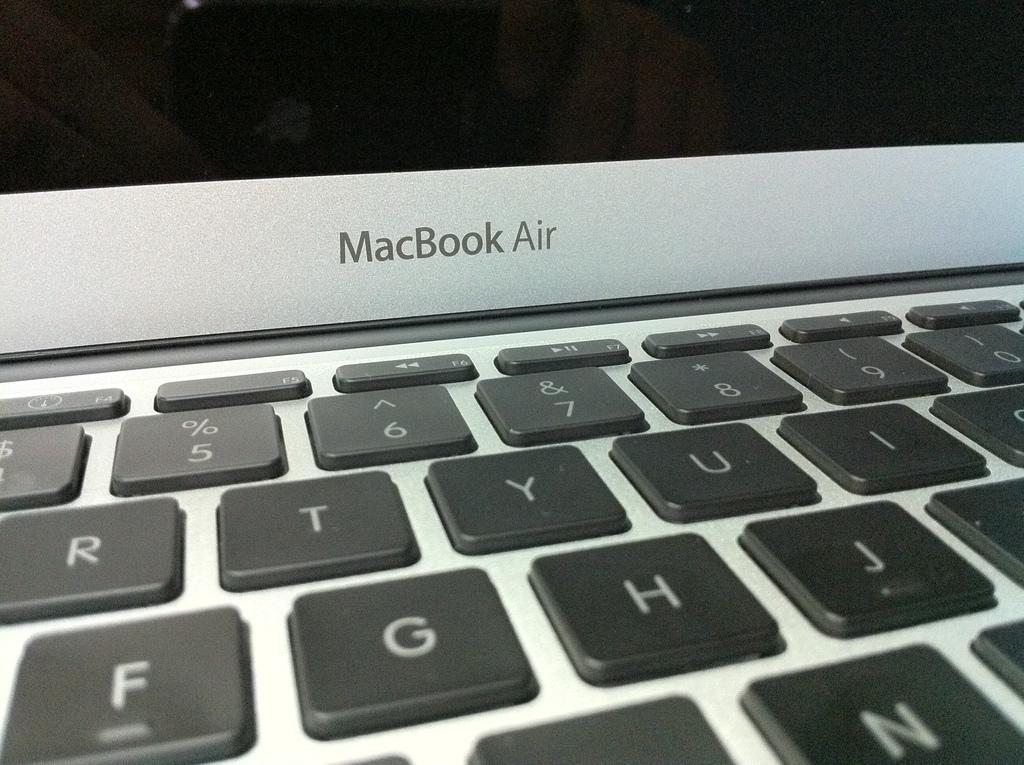Provide a one-sentence caption for the provided image. A MacBook Air is open revealing black keys on a silver laptop. 